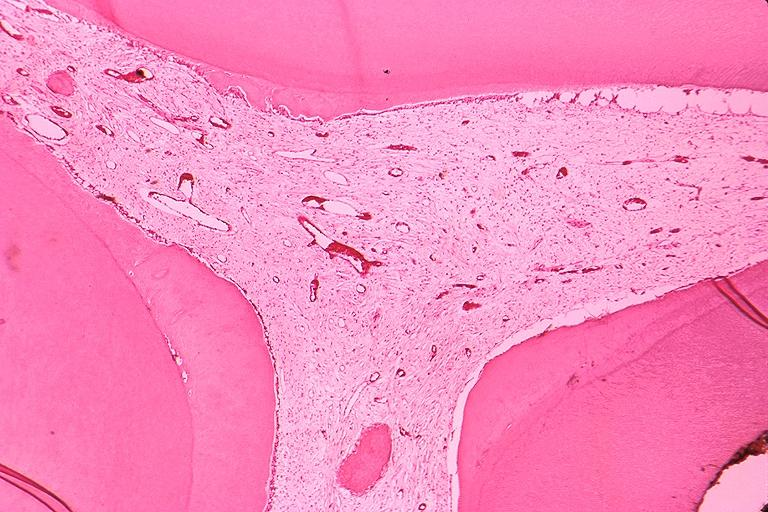where is this?
Answer the question using a single word or phrase. Oral 